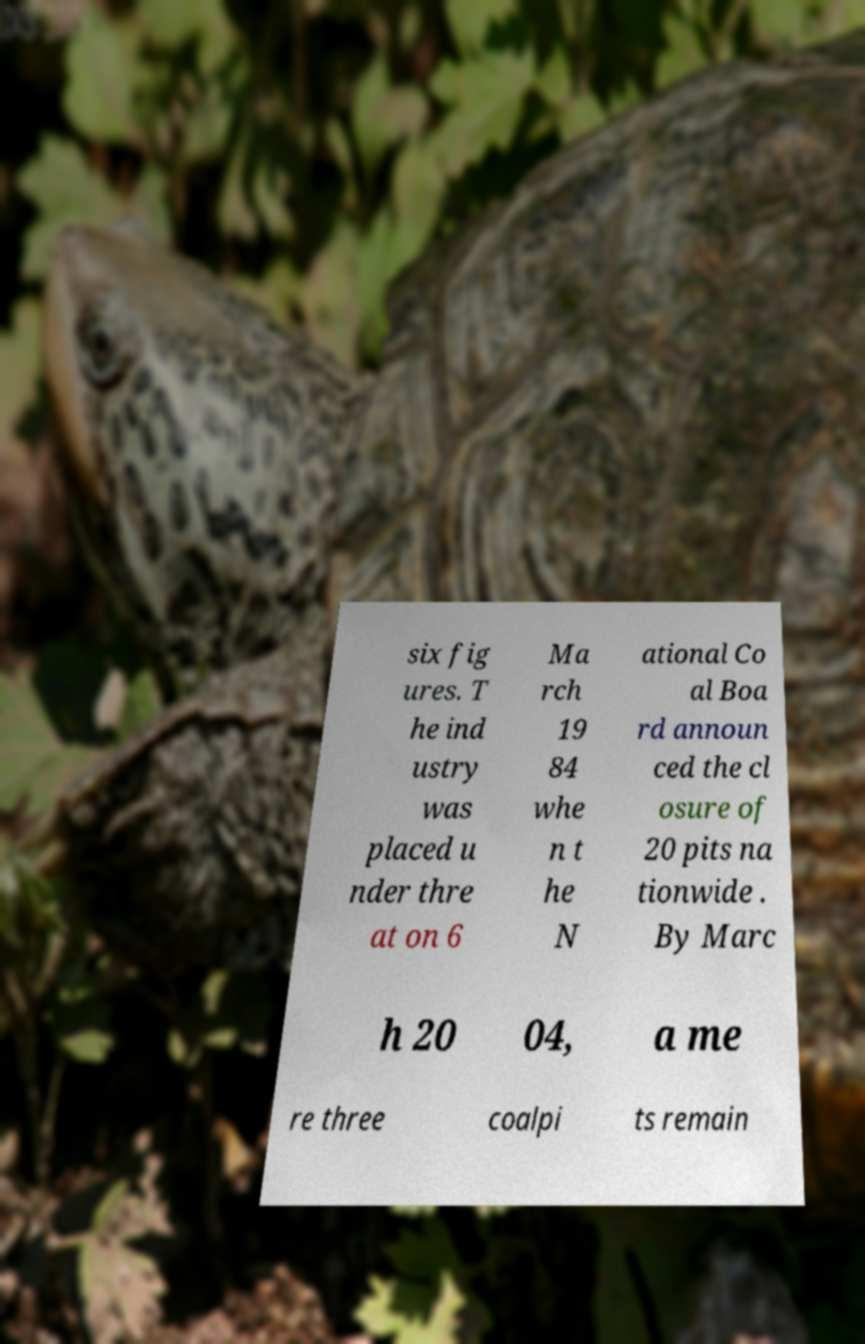Could you assist in decoding the text presented in this image and type it out clearly? six fig ures. T he ind ustry was placed u nder thre at on 6 Ma rch 19 84 whe n t he N ational Co al Boa rd announ ced the cl osure of 20 pits na tionwide . By Marc h 20 04, a me re three coalpi ts remain 